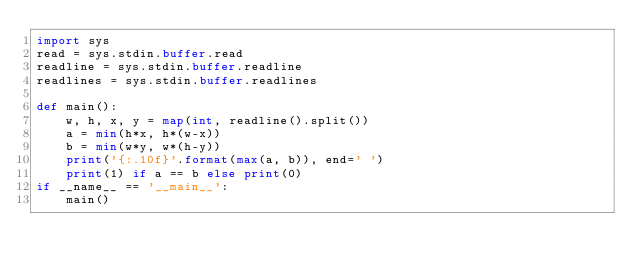Convert code to text. <code><loc_0><loc_0><loc_500><loc_500><_Python_>import sys
read = sys.stdin.buffer.read
readline = sys.stdin.buffer.readline
readlines = sys.stdin.buffer.readlines
 
def main():
    w, h, x, y = map(int, readline().split())
    a = min(h*x, h*(w-x))
    b = min(w*y, w*(h-y))
    print('{:.10f}'.format(max(a, b)), end=' ')
    print(1) if a == b else print(0)
if __name__ == '__main__':
    main()
</code> 